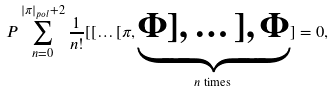Convert formula to latex. <formula><loc_0><loc_0><loc_500><loc_500>P \sum _ { n = 0 } ^ { | \pi | _ { p o l } + 2 } \frac { 1 } { n ! } [ [ \dots [ \pi , \underbrace { \Phi ] , \dots ] , \Phi } _ { n \text { times } } ] = 0 ,</formula> 